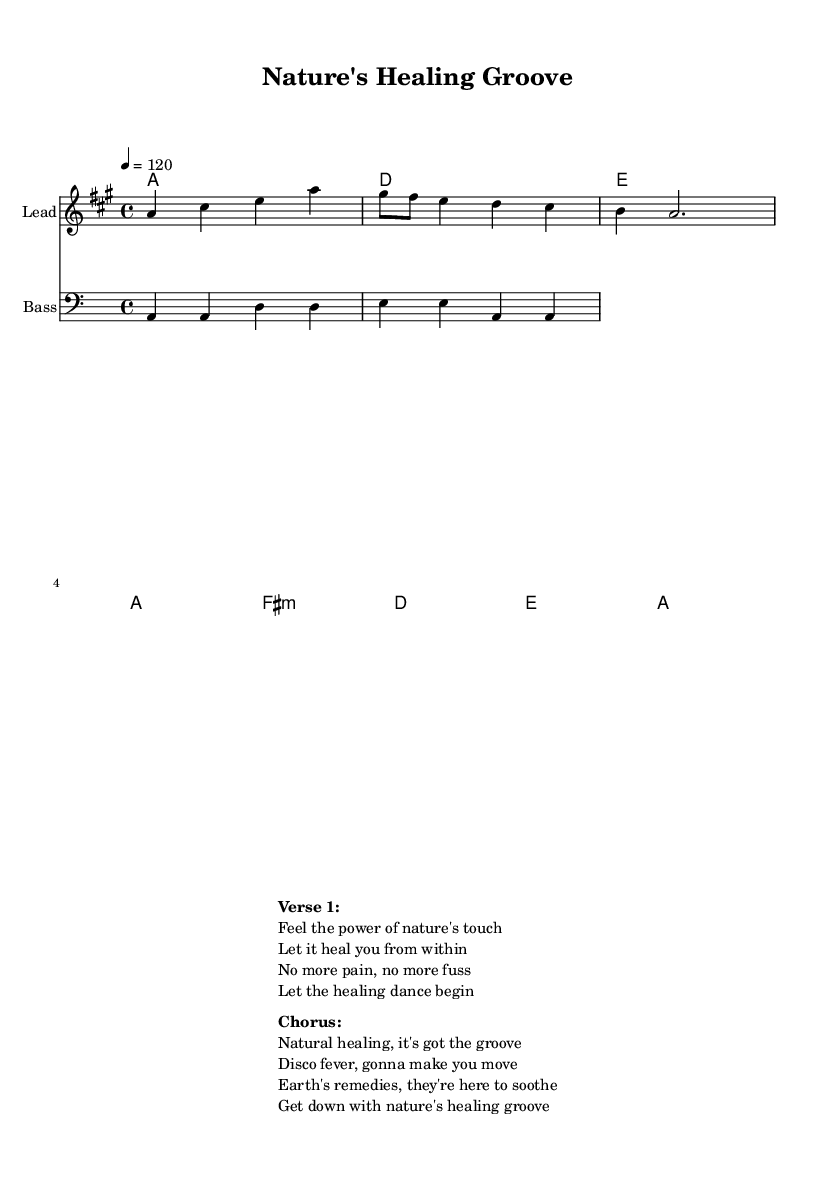What is the key signature of this music? The key signature indicated in the global settings is A major, which has three sharps: F#, C#, and G#.
Answer: A major What is the time signature of this music? The time signature listed in the global settings is 4/4, which means there are four beats in a measure.
Answer: 4/4 What is the tempo marking for this piece? The tempo marking is indicated as "4 = 120," meaning there should be 120 quarter note beats per minute.
Answer: 120 How many measures are in the melody section? By analyzing the melody provided, there are a total of three measures present in the melody section shown.
Answer: 3 measures In what style is this music written? The characteristics of the melody and lyrics suggest that this piece aligns with the Disco style, known for its upbeat and danceable rhythms.
Answer: Disco What phrase is repeated in the chorus? The phrase "Get down with nature's healing groove" is repeated in the chorus, emphasizing the main theme of the piece.
Answer: Get down with nature's healing groove What instrument is used for the bass line? The staff labeled "Bass" indicates that the bass line is specifically written for a bass instrument, as represented by the clef.
Answer: Bass 